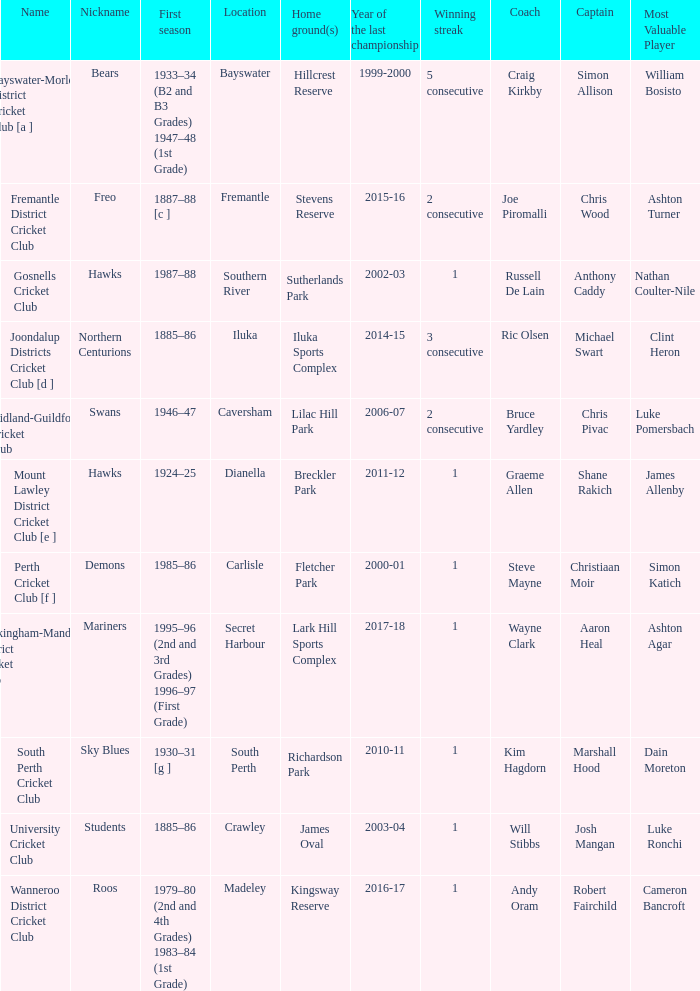What is the code nickname where Steve Mayne is the coach? Demons. 